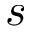Convert formula to latex. <formula><loc_0><loc_0><loc_500><loc_500>s</formula> 